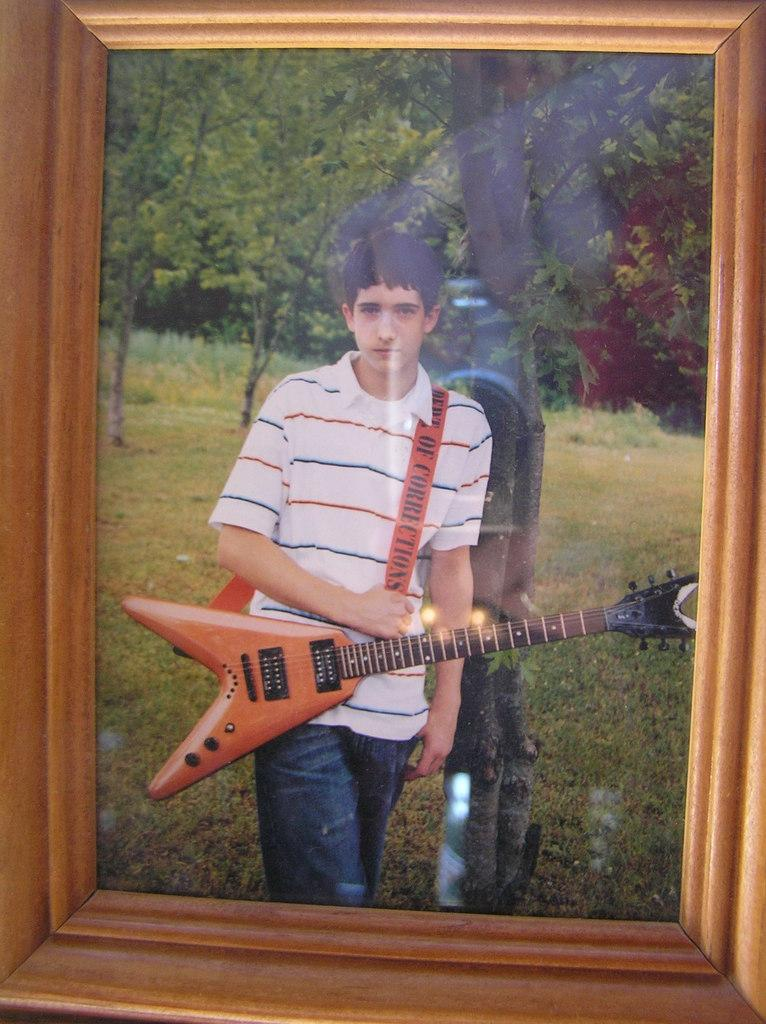What object is present in the image that typically holds a photo? There is a photo frame in the image. What is shown in the photo frame? The photo frame contains a photo of a boy. What is the boy doing in the photo? The boy is standing on a grass surface and holding a guitar. What can be seen in the background of the photo? There are trees visible behind the boy. How many birds are visible in the photo of the boy holding a guitar? There are no birds visible in the photo; the boy is holding a guitar and standing on a grass surface with trees in the background. 